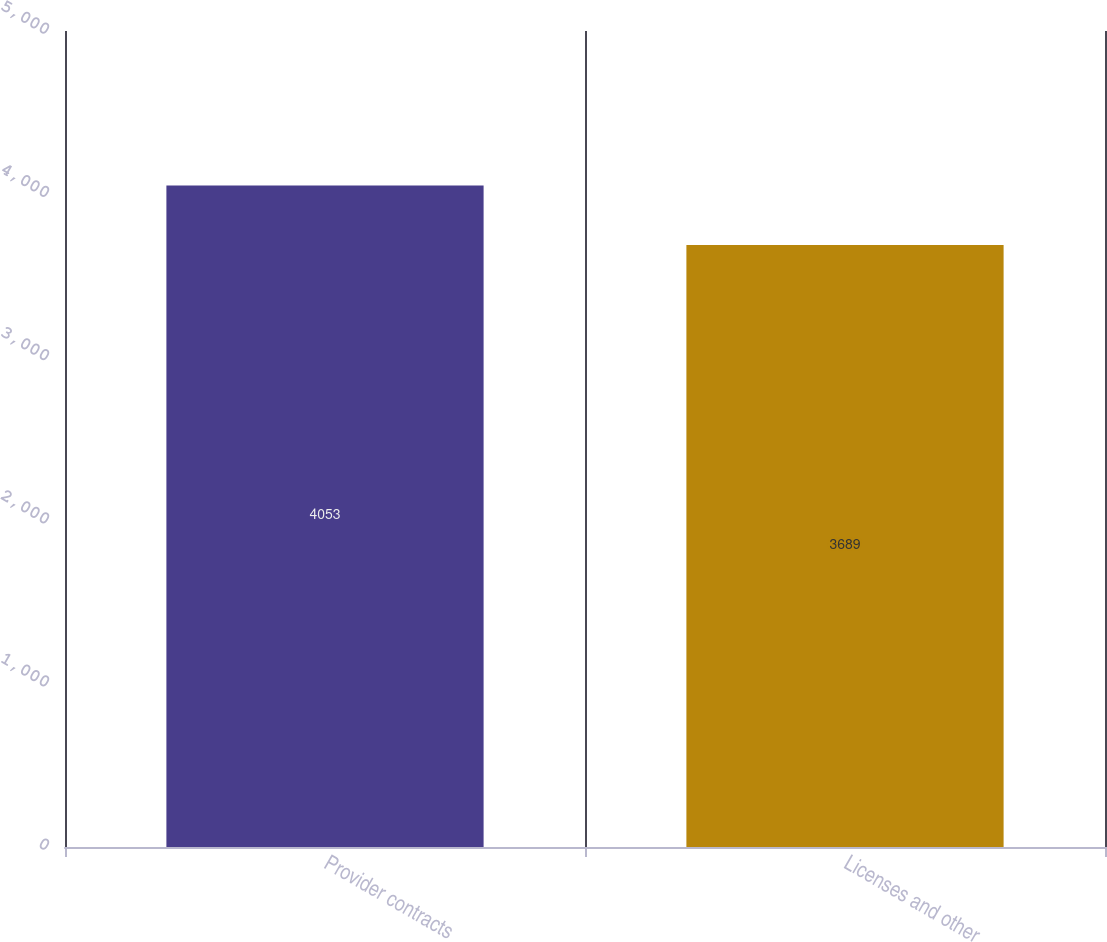Convert chart to OTSL. <chart><loc_0><loc_0><loc_500><loc_500><bar_chart><fcel>Provider contracts<fcel>Licenses and other<nl><fcel>4053<fcel>3689<nl></chart> 